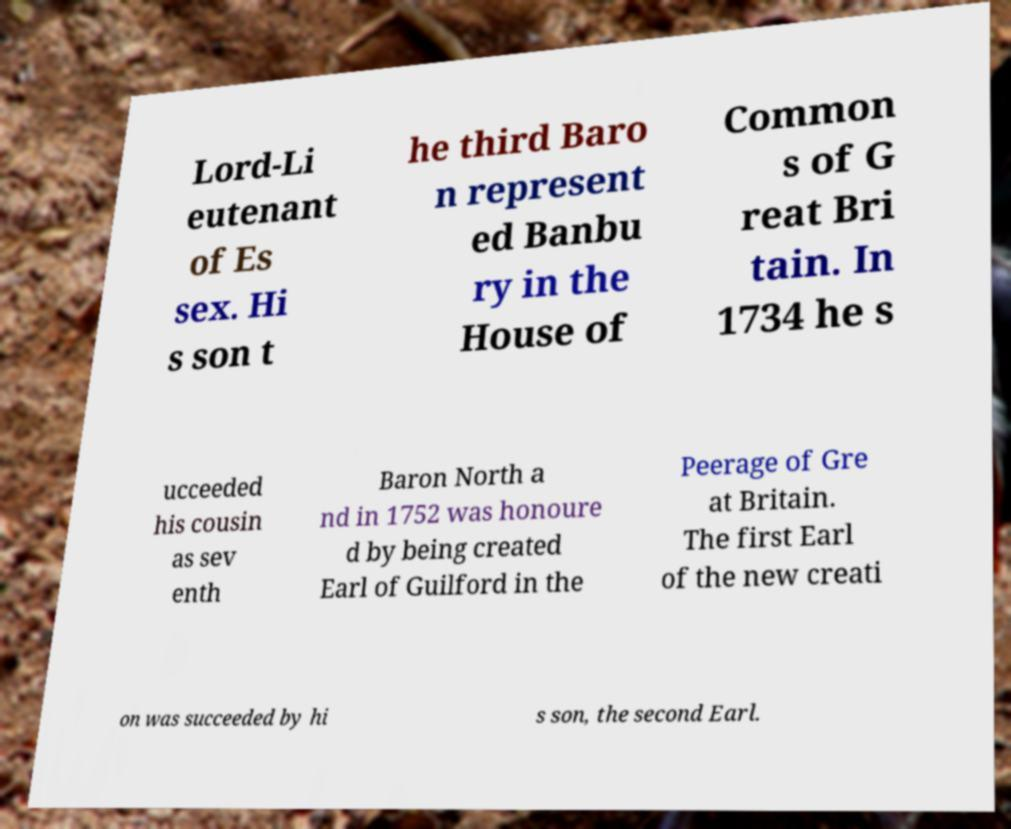Could you extract and type out the text from this image? Lord-Li eutenant of Es sex. Hi s son t he third Baro n represent ed Banbu ry in the House of Common s of G reat Bri tain. In 1734 he s ucceeded his cousin as sev enth Baron North a nd in 1752 was honoure d by being created Earl of Guilford in the Peerage of Gre at Britain. The first Earl of the new creati on was succeeded by hi s son, the second Earl. 